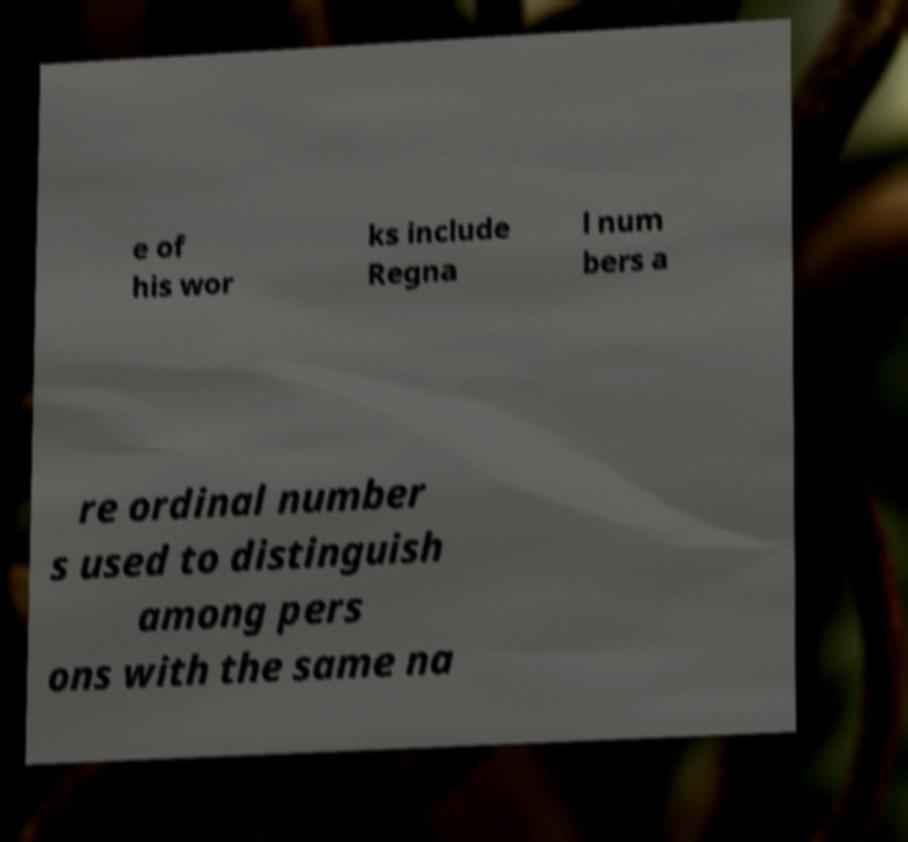For documentation purposes, I need the text within this image transcribed. Could you provide that? e of his wor ks include Regna l num bers a re ordinal number s used to distinguish among pers ons with the same na 